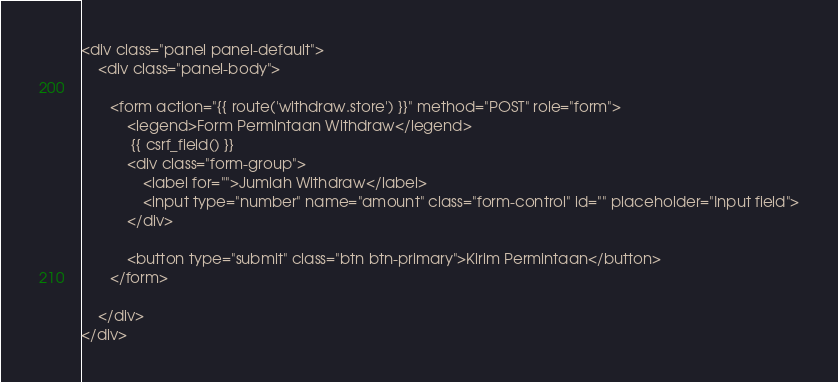Convert code to text. <code><loc_0><loc_0><loc_500><loc_500><_PHP_>
<div class="panel panel-default">
    <div class="panel-body">
       
       <form action="{{ route('withdraw.store') }}" method="POST" role="form">
           <legend>Form Permintaan Withdraw</legend>
            {{ csrf_field() }}
           <div class="form-group">
               <label for="">Jumlah Withdraw</label>
               <input type="number" name="amount" class="form-control" id="" placeholder="Input field">
           </div>
       
           <button type="submit" class="btn btn-primary">Kirim Permintaan</button>
       </form>
       
    </div>
</div>
</code> 